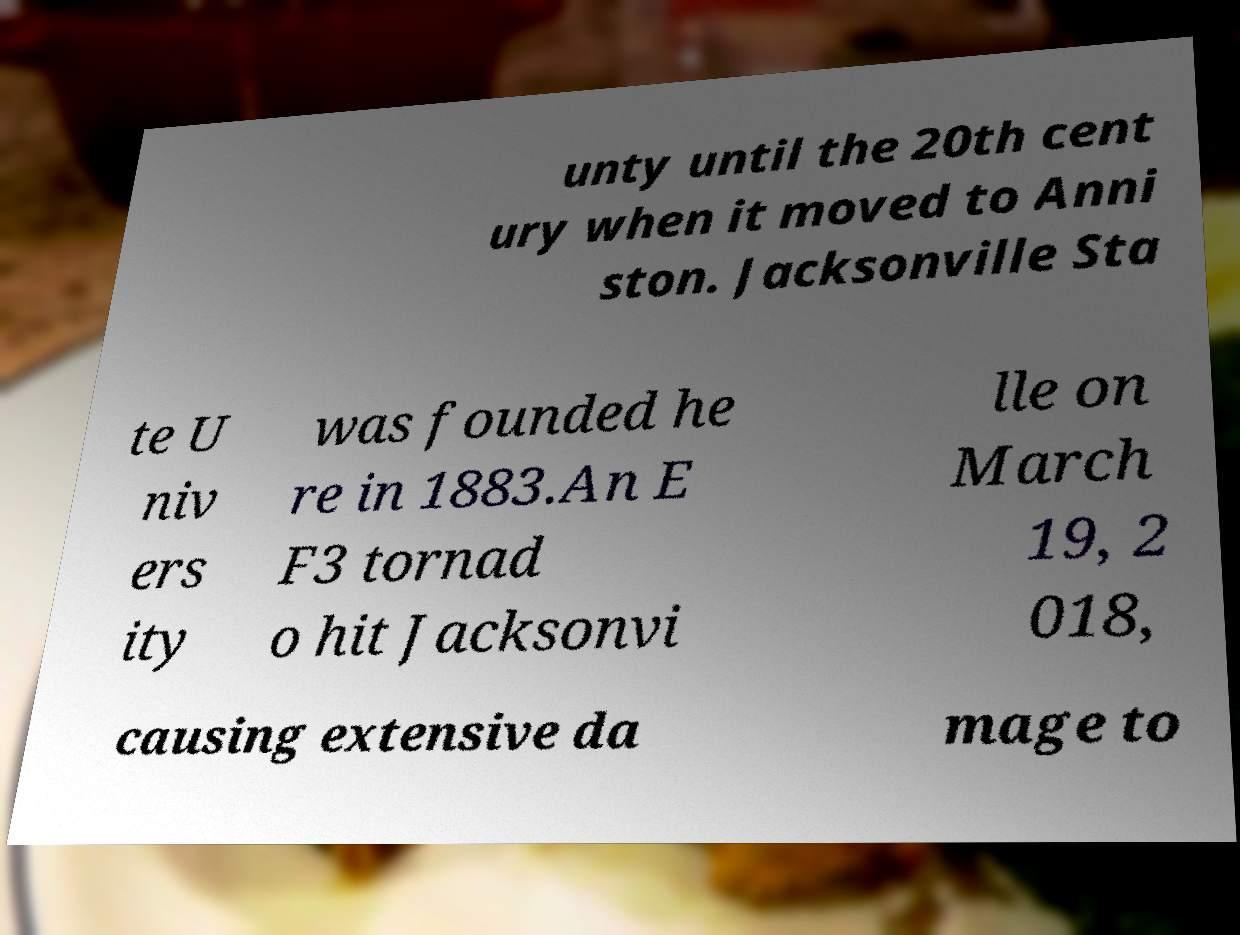Please identify and transcribe the text found in this image. unty until the 20th cent ury when it moved to Anni ston. Jacksonville Sta te U niv ers ity was founded he re in 1883.An E F3 tornad o hit Jacksonvi lle on March 19, 2 018, causing extensive da mage to 